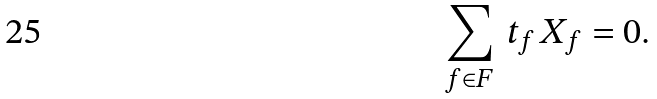Convert formula to latex. <formula><loc_0><loc_0><loc_500><loc_500>\sum _ { f \in F } \, t _ { f } \, X _ { f } = 0 .</formula> 